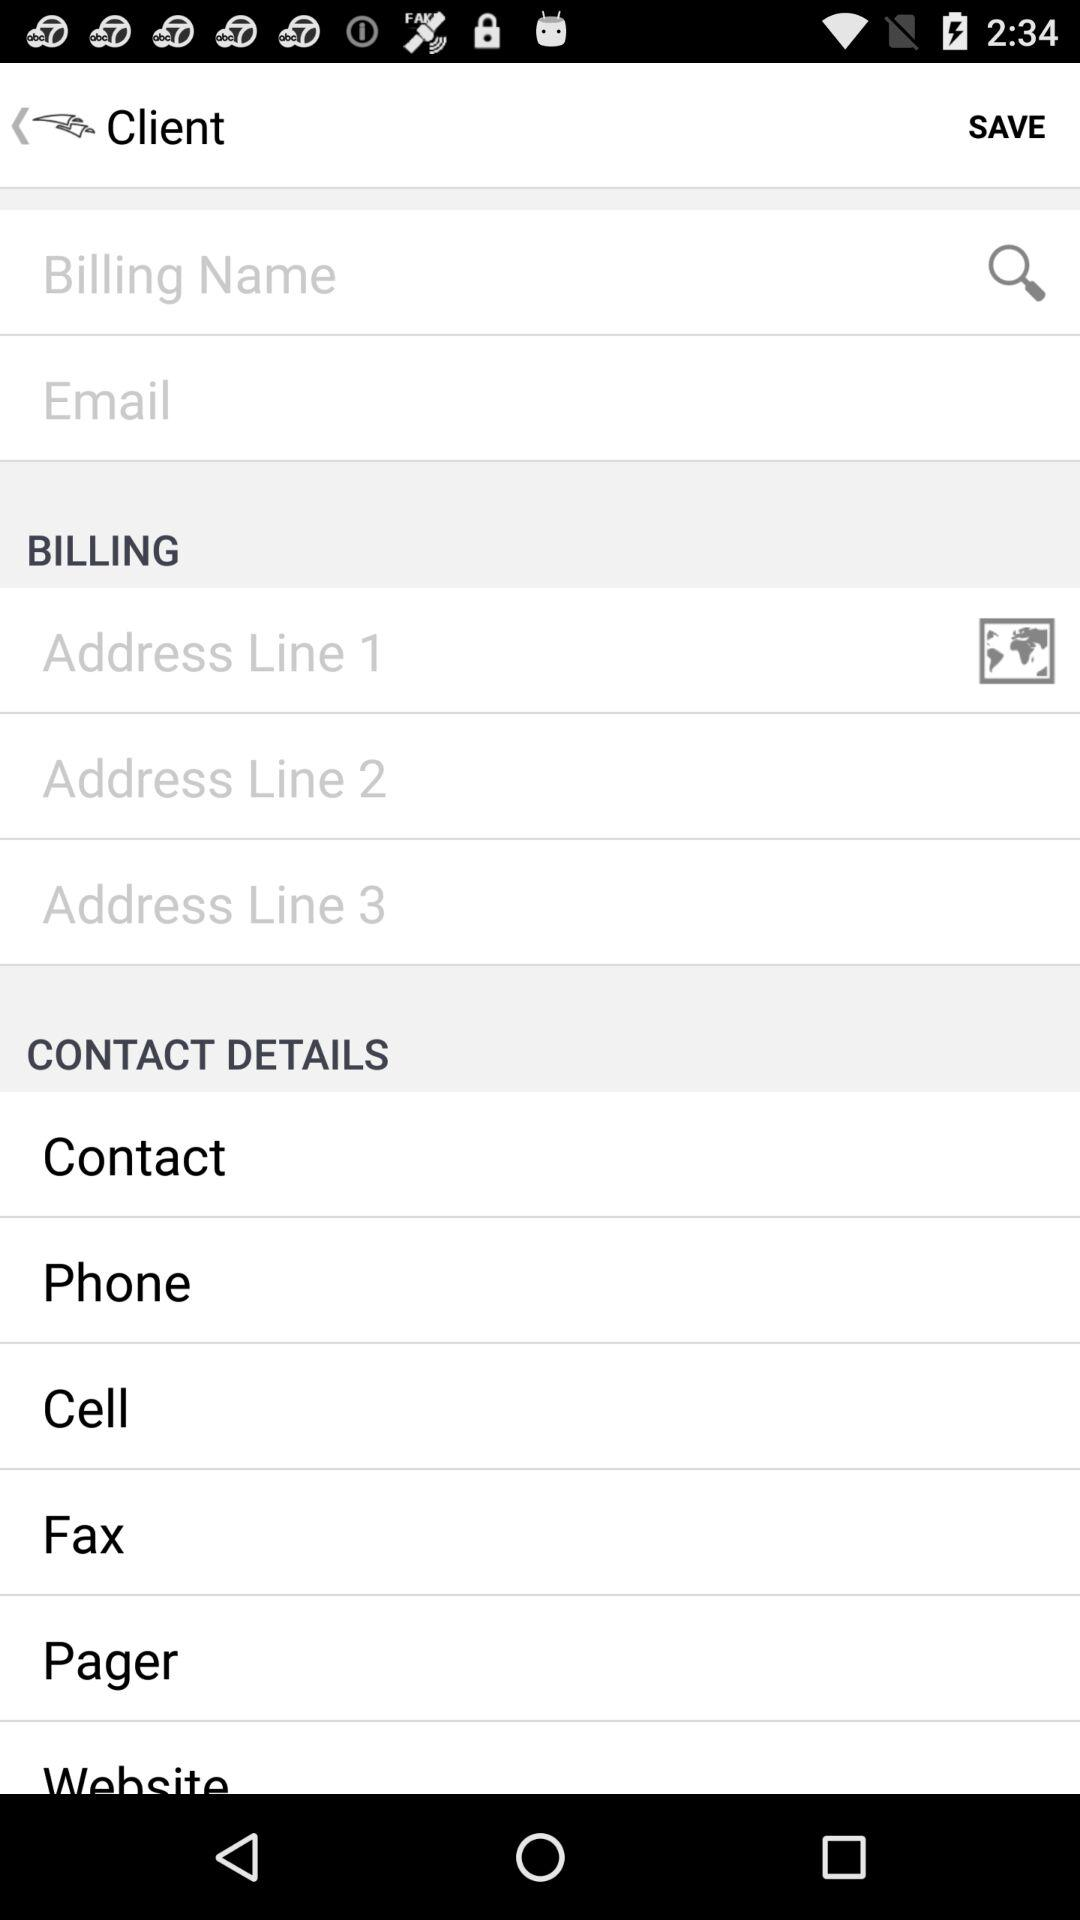How many text inputs are there for address?
Answer the question using a single word or phrase. 3 